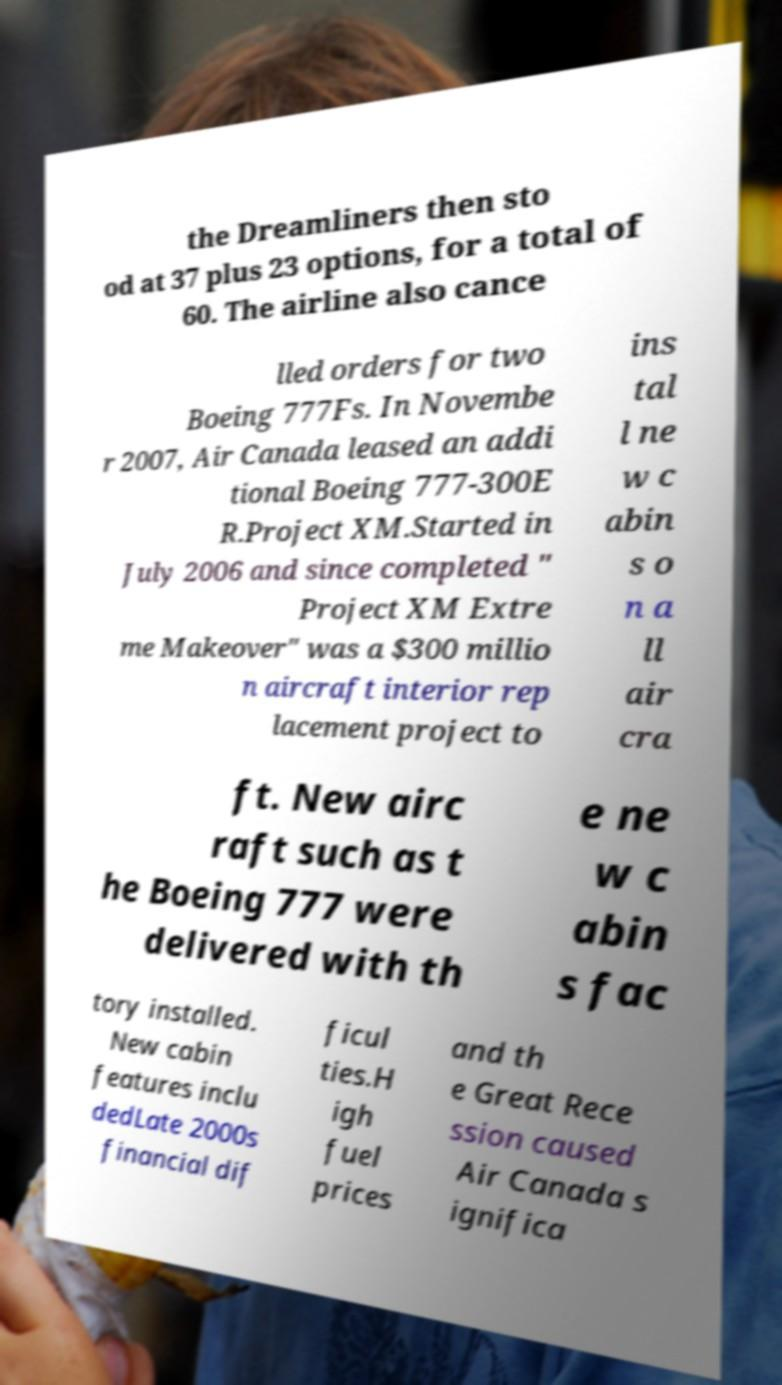Could you extract and type out the text from this image? the Dreamliners then sto od at 37 plus 23 options, for a total of 60. The airline also cance lled orders for two Boeing 777Fs. In Novembe r 2007, Air Canada leased an addi tional Boeing 777-300E R.Project XM.Started in July 2006 and since completed " Project XM Extre me Makeover" was a $300 millio n aircraft interior rep lacement project to ins tal l ne w c abin s o n a ll air cra ft. New airc raft such as t he Boeing 777 were delivered with th e ne w c abin s fac tory installed. New cabin features inclu dedLate 2000s financial dif ficul ties.H igh fuel prices and th e Great Rece ssion caused Air Canada s ignifica 